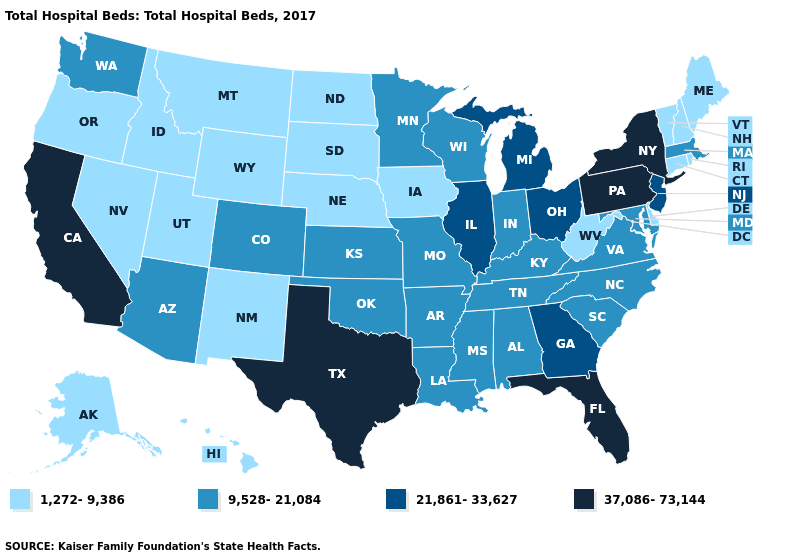What is the value of Nebraska?
Keep it brief. 1,272-9,386. Among the states that border Missouri , which have the lowest value?
Give a very brief answer. Iowa, Nebraska. What is the value of West Virginia?
Give a very brief answer. 1,272-9,386. Name the states that have a value in the range 1,272-9,386?
Be succinct. Alaska, Connecticut, Delaware, Hawaii, Idaho, Iowa, Maine, Montana, Nebraska, Nevada, New Hampshire, New Mexico, North Dakota, Oregon, Rhode Island, South Dakota, Utah, Vermont, West Virginia, Wyoming. What is the value of Kansas?
Short answer required. 9,528-21,084. Does Kansas have a higher value than New Jersey?
Keep it brief. No. Does Ohio have the highest value in the MidWest?
Concise answer only. Yes. Which states have the lowest value in the USA?
Quick response, please. Alaska, Connecticut, Delaware, Hawaii, Idaho, Iowa, Maine, Montana, Nebraska, Nevada, New Hampshire, New Mexico, North Dakota, Oregon, Rhode Island, South Dakota, Utah, Vermont, West Virginia, Wyoming. What is the value of Pennsylvania?
Give a very brief answer. 37,086-73,144. Does Delaware have the lowest value in the USA?
Give a very brief answer. Yes. Does the map have missing data?
Answer briefly. No. Does Hawaii have the highest value in the USA?
Be succinct. No. What is the lowest value in the Northeast?
Write a very short answer. 1,272-9,386. How many symbols are there in the legend?
Give a very brief answer. 4. Does New York have a higher value than Pennsylvania?
Concise answer only. No. 